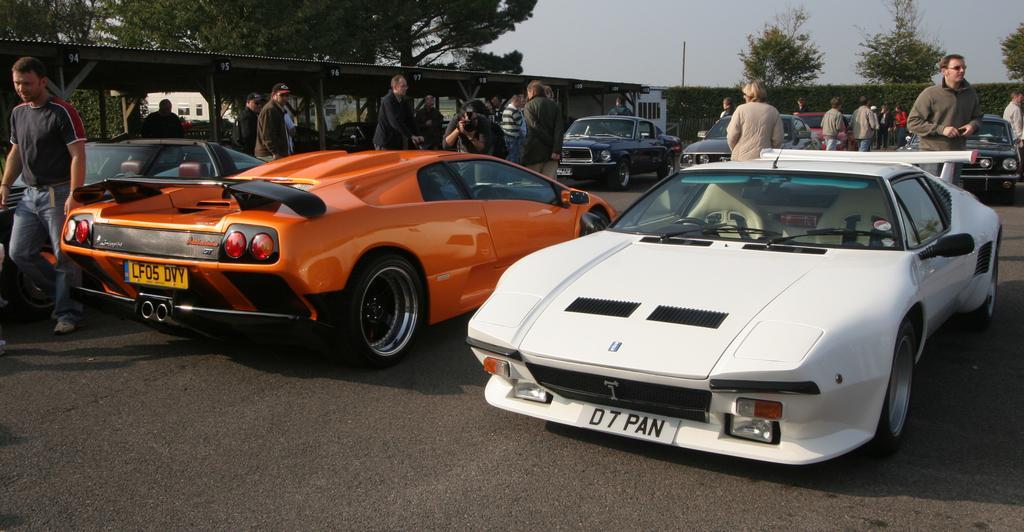Describe this image in one or two sentences. In this image I can see cars on the road. I can also see people are standing. In the background I can see plants, trees, a pole and the sky. 